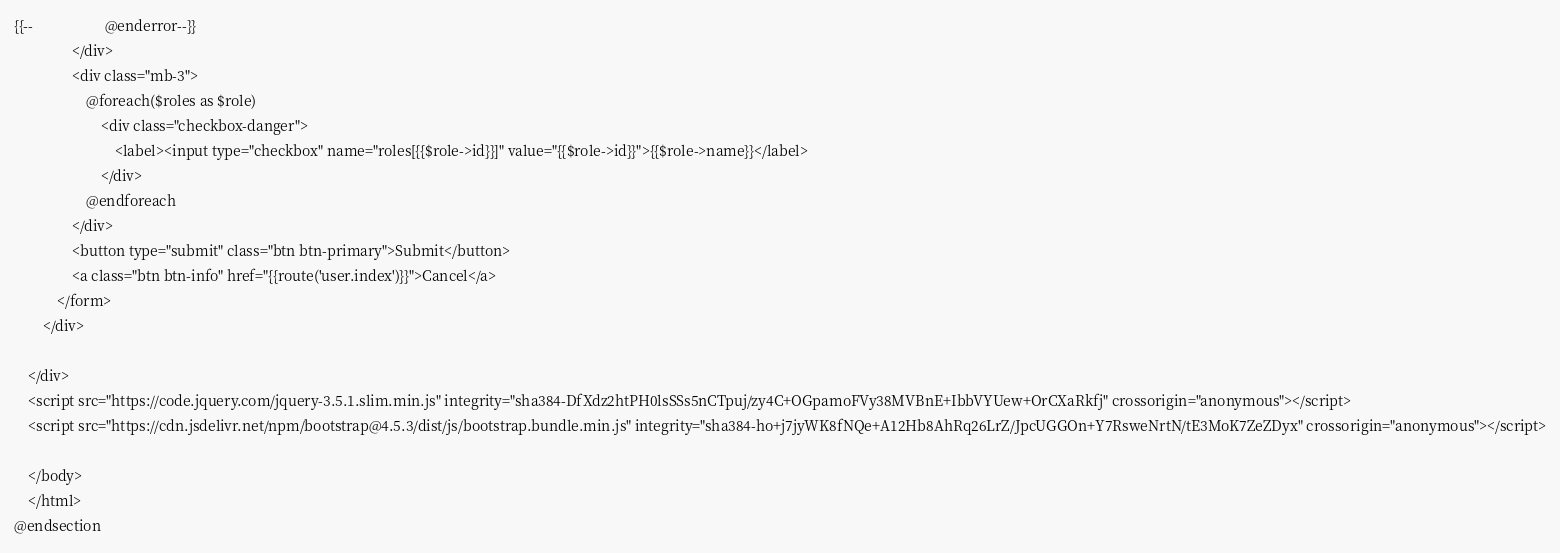Convert code to text. <code><loc_0><loc_0><loc_500><loc_500><_PHP_>{{--                    @enderror--}}
                </div>
                <div class="mb-3">
                    @foreach($roles as $role)
                        <div class="checkbox-danger">
                            <label><input type="checkbox" name="roles[{{$role->id}}]" value="{{$role->id}}">{{$role->name}}</label>
                        </div>
                    @endforeach
                </div>
                <button type="submit" class="btn btn-primary">Submit</button>
                <a class="btn btn-info" href="{{route('user.index')}}">Cancel</a>
            </form>
        </div>

    </div>
    <script src="https://code.jquery.com/jquery-3.5.1.slim.min.js" integrity="sha384-DfXdz2htPH0lsSSs5nCTpuj/zy4C+OGpamoFVy38MVBnE+IbbVYUew+OrCXaRkfj" crossorigin="anonymous"></script>
    <script src="https://cdn.jsdelivr.net/npm/bootstrap@4.5.3/dist/js/bootstrap.bundle.min.js" integrity="sha384-ho+j7jyWK8fNQe+A12Hb8AhRq26LrZ/JpcUGGOn+Y7RsweNrtN/tE3MoK7ZeZDyx" crossorigin="anonymous"></script>

    </body>
    </html>
@endsection
</code> 